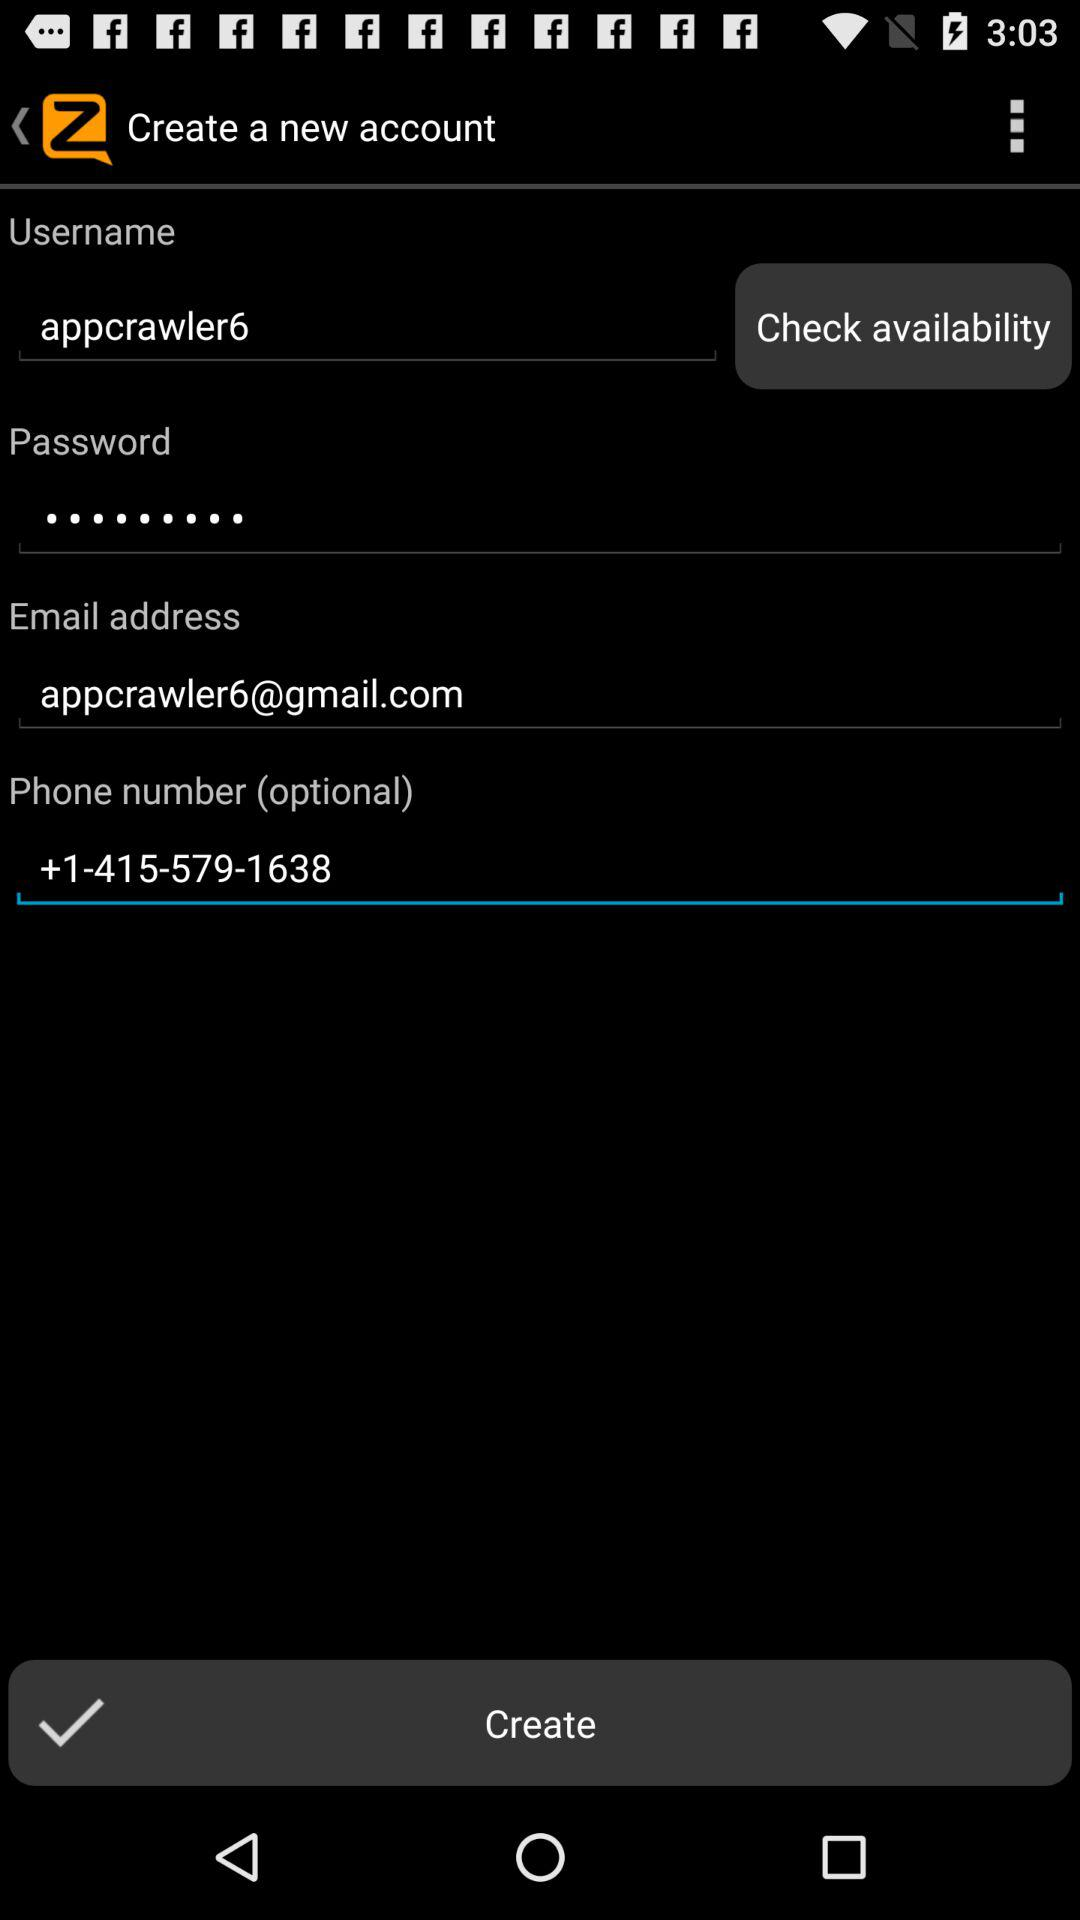What is the email address? The email address is appcrawler6@gmail.com. 